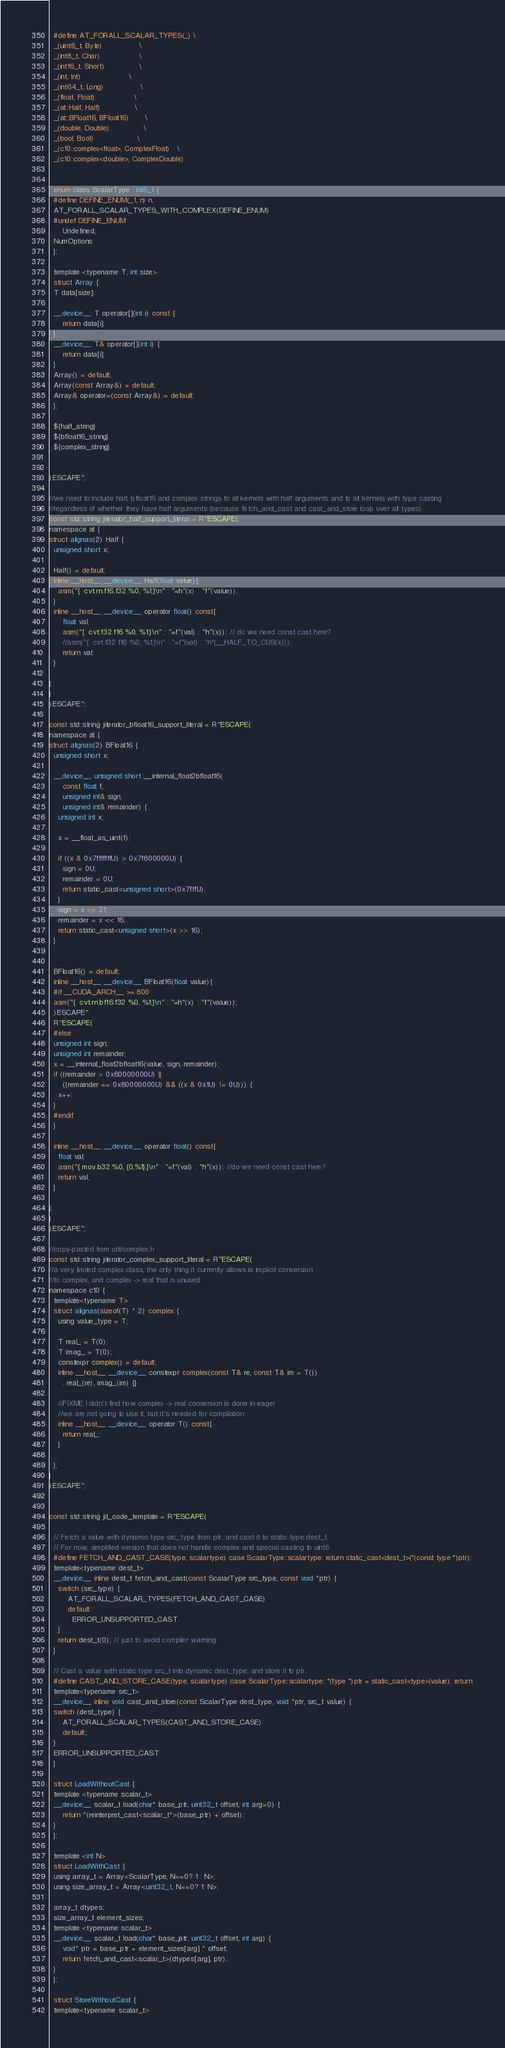Convert code to text. <code><loc_0><loc_0><loc_500><loc_500><_Cuda_>  #define AT_FORALL_SCALAR_TYPES(_) \
  _(uint8_t, Byte)                \
  _(int8_t, Char)                 \
  _(int16_t, Short)               \
  _(int, Int)                     \
  _(int64_t, Long)                \
  _(float, Float)                 \
  _(at::Half, Half)               \
  _(at::BFloat16, BFloat16)       \
  _(double, Double)               \
  _(bool, Bool)                   \
  _(c10::complex<float>, ComplexFloat)   \
  _(c10::complex<double>, ComplexDouble)


  enum class ScalarType : int8_t {
  #define DEFINE_ENUM(_1, n) n,
  AT_FORALL_SCALAR_TYPES_WITH_COMPLEX(DEFINE_ENUM)
  #undef DEFINE_ENUM
      Undefined,
  NumOptions
  };

  template <typename T, int size>
  struct Array {
  T data[size];

  __device__ T operator[](int i) const {
      return data[i];
  }
  __device__ T& operator[](int i) {
      return data[i];
  }
  Array() = default;
  Array(const Array&) = default;
  Array& operator=(const Array&) = default;
  };

  ${half_string}
  ${bfloat16_string}
  ${complex_string}


)ESCAPE";

//we need to include half, bfloat16 and complex strings to all kernels with half arguments and to all kernels with type casting
//regardless of whether they have half arguments (because fetch_and_cast and cast_and_store loop over all types)
const std::string jiterator_half_support_literal = R"ESCAPE(
namespace at {
struct alignas(2) Half {
  unsigned short x;

  Half() = default;
  inline __host__ __device__ Half(float value){
    asm("{  cvt.rn.f16.f32 %0, %1;}\n" : "=h"(x) : "f"(value));
  }
  inline __host__ __device__ operator float() const{
      float val;
      asm("{  cvt.f32.f16 %0, %1;}\n" : "=f"(val) : "h"(x)); // do we need const cast here?
      //asm("{  cvt.f32.f16 %0, %1;}\n" : "=f"(val) : "h"(__HALF_TO_CUS(x)));
      return val;
  }

};
}
)ESCAPE";

const std::string jiterator_bfloat16_support_literal = R"ESCAPE(
namespace at {
struct alignas(2) BFloat16 {
  unsigned short x;

  __device__ unsigned short __internal_float2bfloat16(
      const float f,
      unsigned int& sign,
      unsigned int& remainder) {
    unsigned int x;

    x = __float_as_uint(f);

    if ((x & 0x7fffffffU) > 0x7f800000U) {
      sign = 0U;
      remainder = 0U;
      return static_cast<unsigned short>(0x7fffU);
    }
    sign = x >> 31;
    remainder = x << 16;
    return static_cast<unsigned short>(x >> 16);
  }


  BFloat16() = default;
  inline __host__ __device__ BFloat16(float value){
  #if __CUDA_ARCH__ >= 800
  asm("{  cvt.rn.bf16.f32 %0, %1;}\n" : "=h"(x) : "f"(value));
  )ESCAPE"
  R"ESCAPE(
  #else
  unsigned int sign;
  unsigned int remainder;
  x = __internal_float2bfloat16(value, sign, remainder);
  if ((remainder > 0x80000000U) ||
      ((remainder == 0x80000000U) && ((x & 0x1U) != 0U))) {
    x++;
  }
  #endif
  }

  inline __host__ __device__ operator float() const{
    float val;
    asm("{ mov.b32 %0, {0,%1};}\n" : "=f"(val) : "h"(x)); //do we need const cast here?
    return val;
  }

};
}
)ESCAPE";

//copy-pasted from util/complex.h
const std::string jiterator_complex_support_literal = R"ESCAPE(
//a very limited complex class, the only thing it currently allows is implicit conversion
//to complex, and complex -> real that is unused
namespace c10 {
  template<typename T>
  struct alignas(sizeof(T) * 2) complex {
    using value_type = T;

    T real_ = T(0);
    T imag_ = T(0);
    constexpr complex() = default;
    inline __host__ __device__ constexpr complex(const T& re, const T& im = T())
      : real_(re), imag_(im) {}

    //FIXME I didn't find how complex -> real conversion is done in eager
    //we are not going to use it, but it's needed for compilation
    inline __host__ __device__ operator T() const{
      return real_;
    }

  };
}
)ESCAPE";


const std::string jit_code_template = R"ESCAPE(

  // Fetch a value with dynamic type src_type from ptr, and cast it to static type dest_t.
  // For now, simplified version that does not handle complex and special casting to uint8
  #define FETCH_AND_CAST_CASE(type, scalartype) case ScalarType::scalartype: return static_cast<dest_t>(*(const type *)ptr);
  template<typename dest_t>
  __device__ inline dest_t fetch_and_cast(const ScalarType src_type, const void *ptr) {
    switch (src_type) {
        AT_FORALL_SCALAR_TYPES(FETCH_AND_CAST_CASE)
        default:
          ERROR_UNSUPPORTED_CAST
    }
    return dest_t(0); // just to avoid compiler warning
  }

  // Cast a value with static type src_t into dynamic dest_type, and store it to ptr.
  #define CAST_AND_STORE_CASE(type, scalartype) case ScalarType::scalartype: *(type *)ptr = static_cast<type>(value); return;
  template<typename src_t>
  __device__ inline void cast_and_store(const ScalarType dest_type, void *ptr, src_t value) {
  switch (dest_type) {
      AT_FORALL_SCALAR_TYPES(CAST_AND_STORE_CASE)
      default:;
  }
  ERROR_UNSUPPORTED_CAST
  }

  struct LoadWithoutCast {
  template <typename scalar_t>
  __device__ scalar_t load(char* base_ptr, uint32_t offset, int arg=0) {
      return *(reinterpret_cast<scalar_t*>(base_ptr) + offset);
  }
  };

  template <int N>
  struct LoadWithCast {
  using array_t = Array<ScalarType, N==0? 1 : N>;
  using size_array_t = Array<uint32_t, N==0? 1: N>;

  array_t dtypes;
  size_array_t element_sizes;
  template <typename scalar_t>
  __device__ scalar_t load(char* base_ptr, uint32_t offset, int arg) {
      void* ptr = base_ptr + element_sizes[arg] * offset;
      return fetch_and_cast<scalar_t>(dtypes[arg], ptr);
  }
  };

  struct StoreWithoutCast {
  template<typename scalar_t></code> 